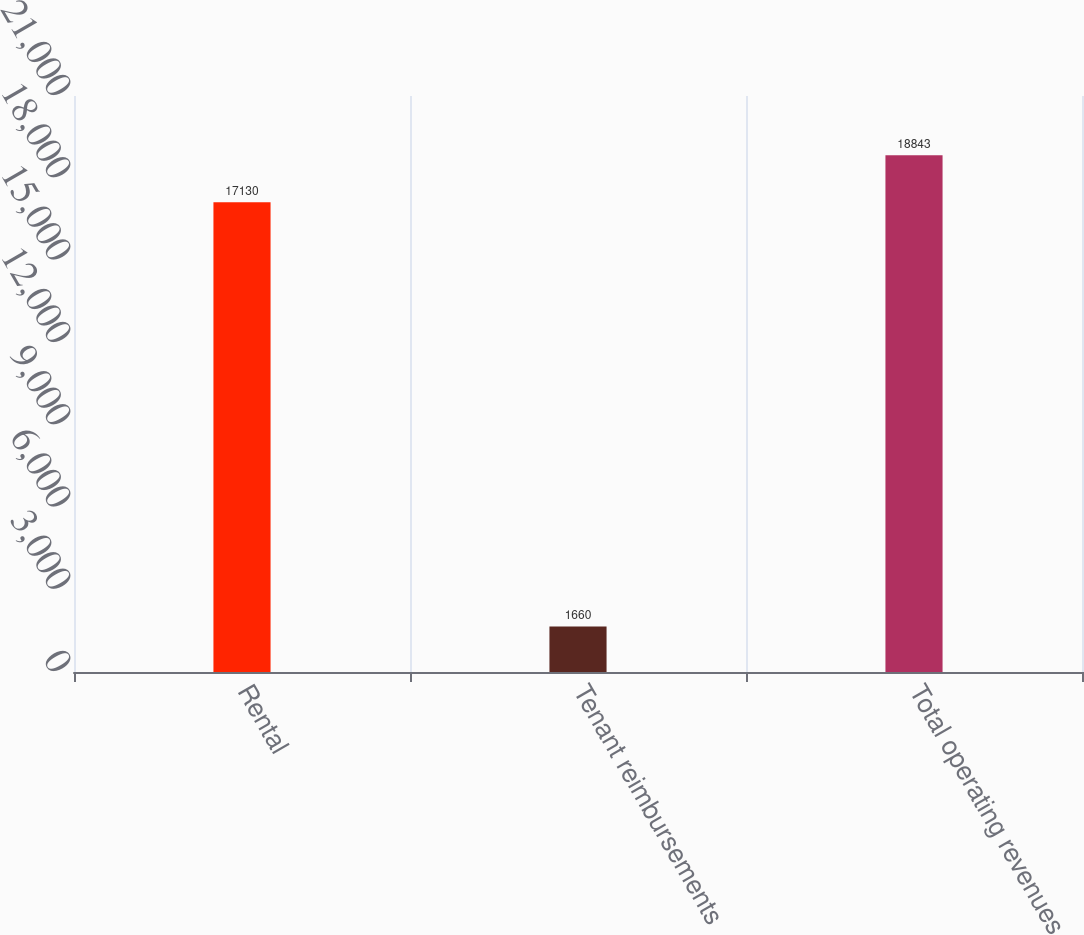Convert chart. <chart><loc_0><loc_0><loc_500><loc_500><bar_chart><fcel>Rental<fcel>Tenant reimbursements<fcel>Total operating revenues<nl><fcel>17130<fcel>1660<fcel>18843<nl></chart> 